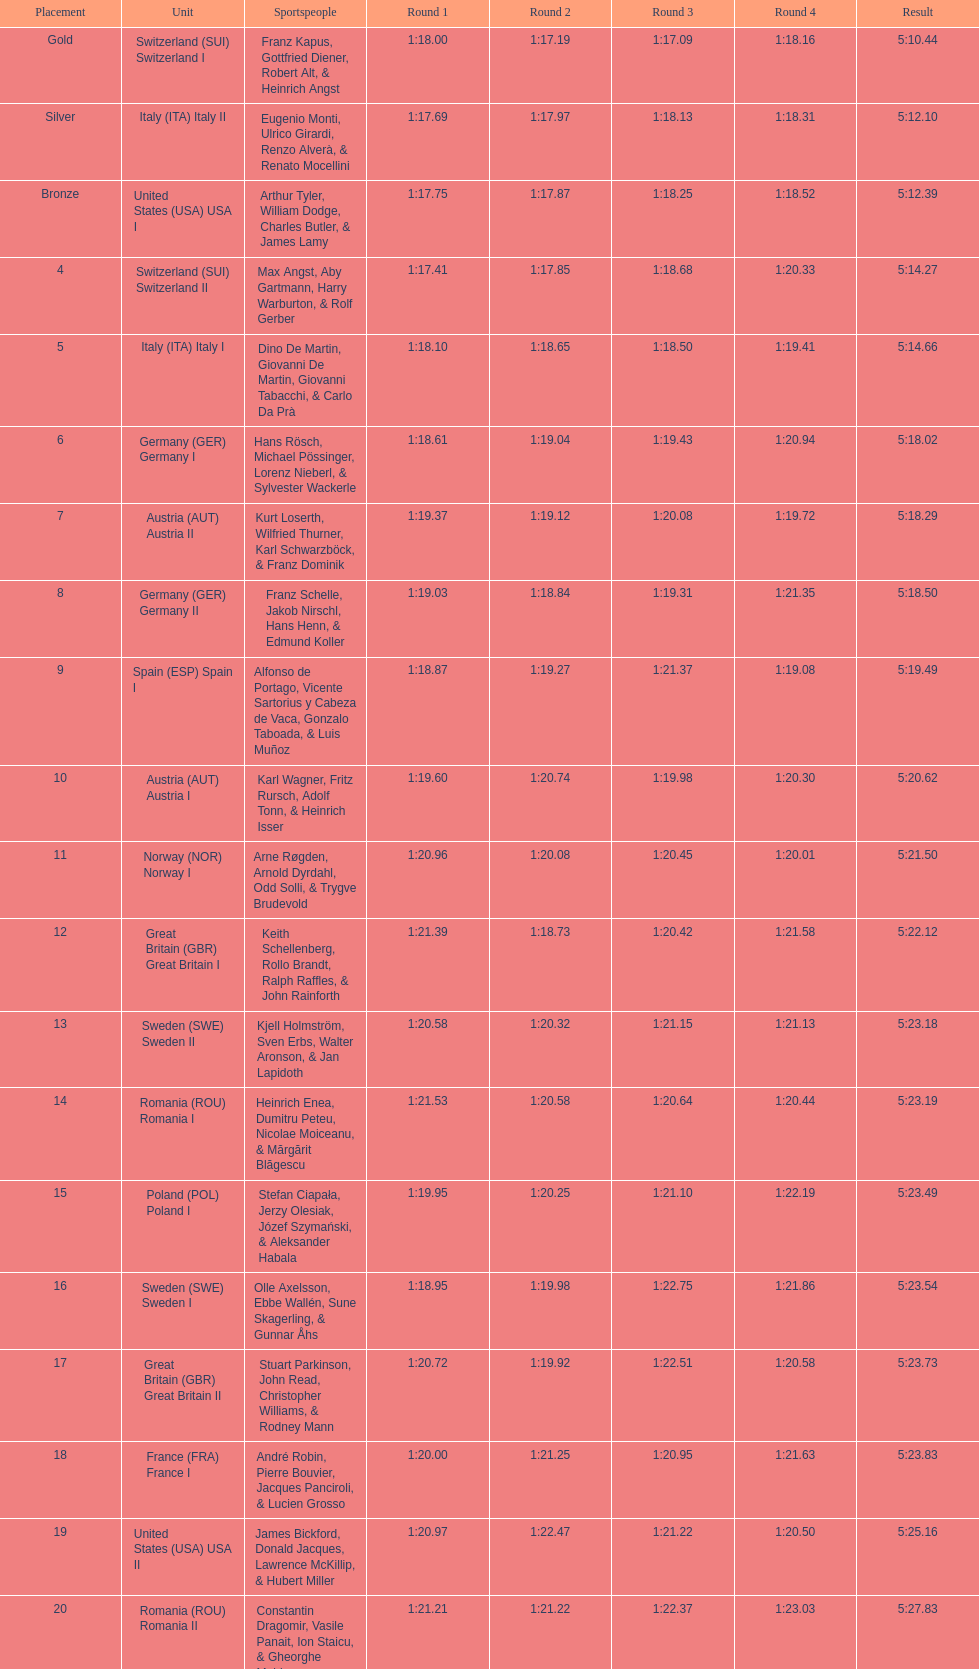Which team won the most runs? Switzerland. 